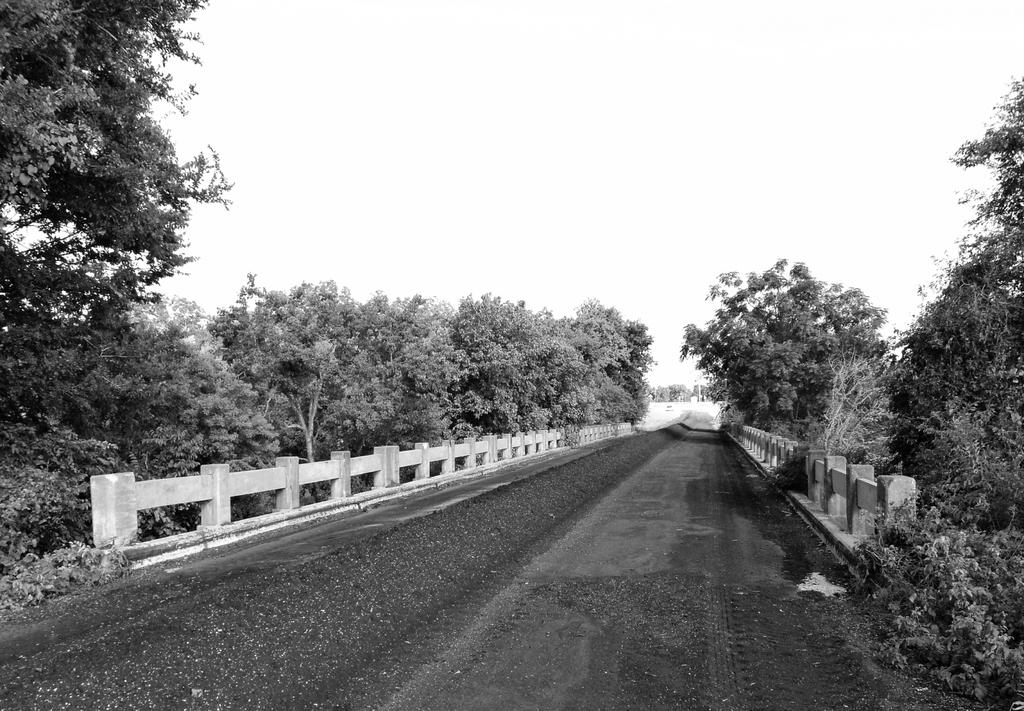What is the color scheme of the image? The image is black and white. What can be seen in the image? There is a road and a concrete fence beside the road. What is located near the fence? There are trees on either side of the fence. Who is the owner of the beef in the image? There is no beef present in the image, so it is not possible to determine the owner. 